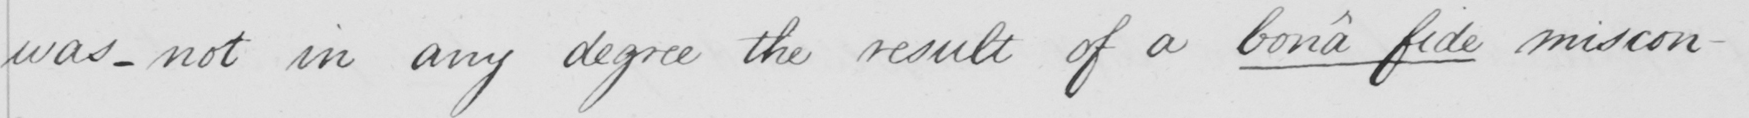What does this handwritten line say? was _ not in any degree the result of a  bona fide  miscon- 